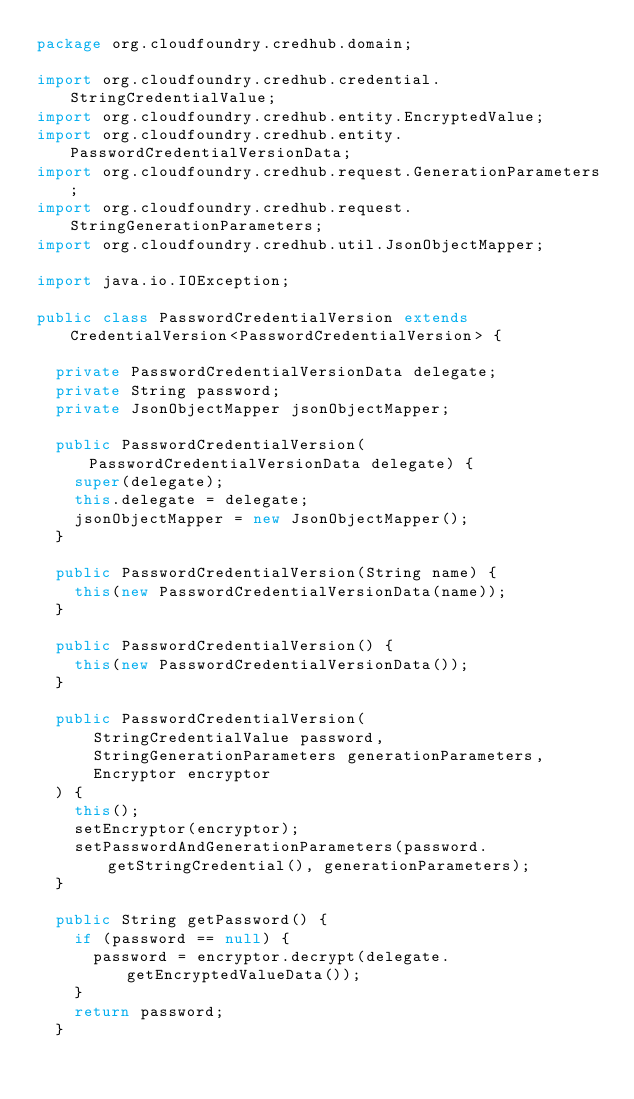Convert code to text. <code><loc_0><loc_0><loc_500><loc_500><_Java_>package org.cloudfoundry.credhub.domain;

import org.cloudfoundry.credhub.credential.StringCredentialValue;
import org.cloudfoundry.credhub.entity.EncryptedValue;
import org.cloudfoundry.credhub.entity.PasswordCredentialVersionData;
import org.cloudfoundry.credhub.request.GenerationParameters;
import org.cloudfoundry.credhub.request.StringGenerationParameters;
import org.cloudfoundry.credhub.util.JsonObjectMapper;

import java.io.IOException;

public class PasswordCredentialVersion extends CredentialVersion<PasswordCredentialVersion> {

  private PasswordCredentialVersionData delegate;
  private String password;
  private JsonObjectMapper jsonObjectMapper;

  public PasswordCredentialVersion(PasswordCredentialVersionData delegate) {
    super(delegate);
    this.delegate = delegate;
    jsonObjectMapper = new JsonObjectMapper();
  }

  public PasswordCredentialVersion(String name) {
    this(new PasswordCredentialVersionData(name));
  }

  public PasswordCredentialVersion() {
    this(new PasswordCredentialVersionData());
  }

  public PasswordCredentialVersion(
      StringCredentialValue password,
      StringGenerationParameters generationParameters,
      Encryptor encryptor
  ) {
    this();
    setEncryptor(encryptor);
    setPasswordAndGenerationParameters(password.getStringCredential(), generationParameters);
  }

  public String getPassword() {
    if (password == null) {
      password = encryptor.decrypt(delegate.getEncryptedValueData());
    }
    return password;
  }
</code> 